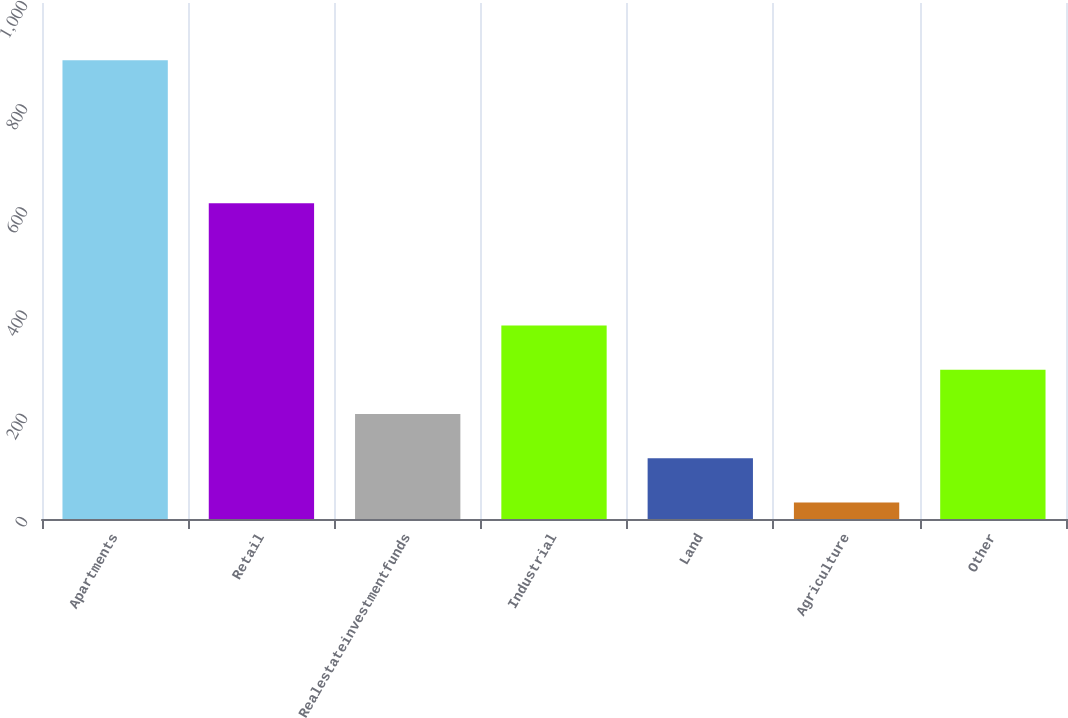<chart> <loc_0><loc_0><loc_500><loc_500><bar_chart><fcel>Apartments<fcel>Retail<fcel>Realestateinvestmentfunds<fcel>Industrial<fcel>Land<fcel>Agriculture<fcel>Other<nl><fcel>889<fcel>612<fcel>203.4<fcel>374.8<fcel>117.7<fcel>32<fcel>289.1<nl></chart> 